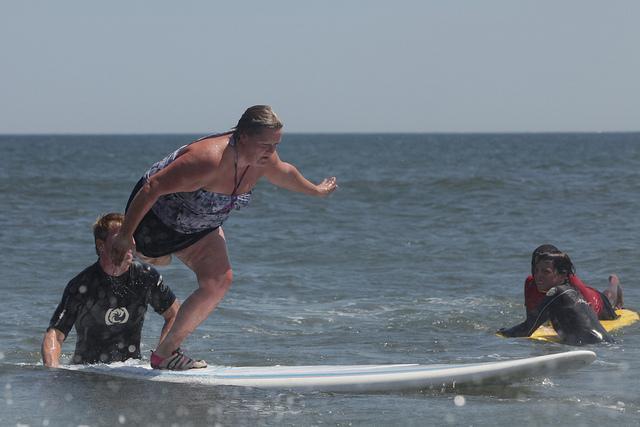How many people are in the water?
Give a very brief answer. 2. How many people are seen?
Give a very brief answer. 4. How many people are in the photo?
Give a very brief answer. 3. 